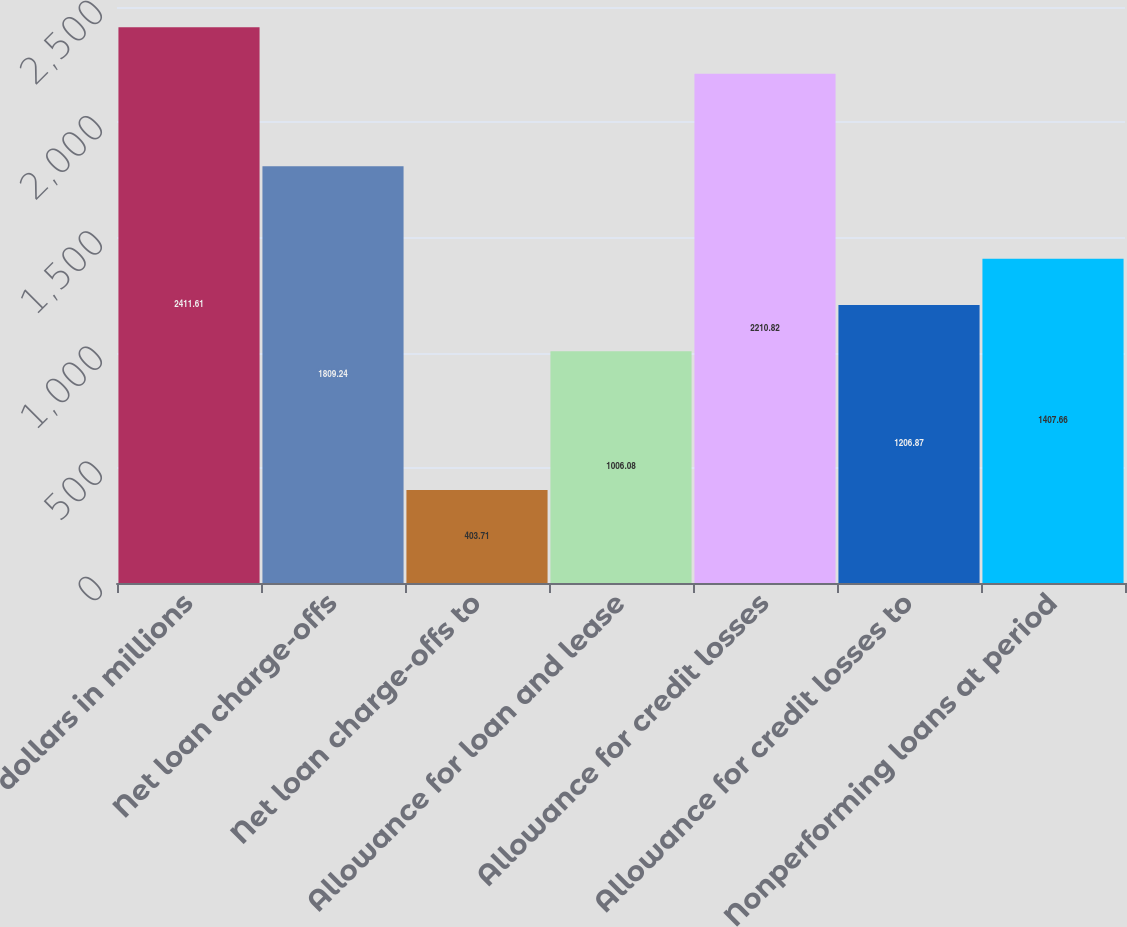Convert chart to OTSL. <chart><loc_0><loc_0><loc_500><loc_500><bar_chart><fcel>dollars in millions<fcel>Net loan charge-offs<fcel>Net loan charge-offs to<fcel>Allowance for loan and lease<fcel>Allowance for credit losses<fcel>Allowance for credit losses to<fcel>Nonperforming loans at period<nl><fcel>2411.61<fcel>1809.24<fcel>403.71<fcel>1006.08<fcel>2210.82<fcel>1206.87<fcel>1407.66<nl></chart> 